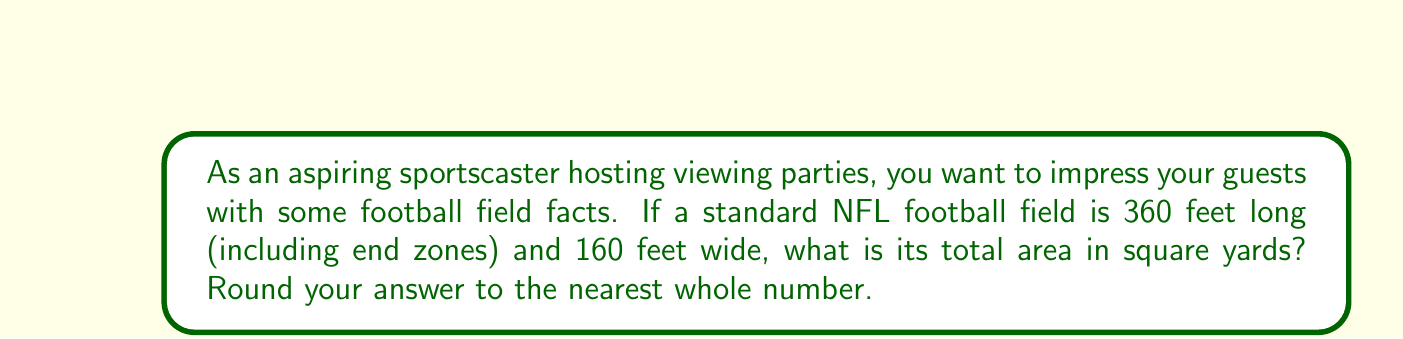Provide a solution to this math problem. Let's approach this step-by-step:

1) First, we need to recall the formula for the area of a rectangle:
   $$A = l \times w$$
   where $A$ is the area, $l$ is the length, and $w$ is the width.

2) We're given the dimensions in feet:
   Length ($l$) = 360 feet
   Width ($w$) = 160 feet

3) Let's substitute these into our formula:
   $$A = 360 \text{ ft} \times 160 \text{ ft} = 57,600 \text{ sq ft}$$

4) However, the question asks for the area in square yards. We need to convert square feet to square yards.

5) The conversion factor is: 1 square yard = 9 square feet
   So, we divide our result by 9:
   $$A_{\text{yards}} = \frac{57,600 \text{ sq ft}}{9 \text{ sq ft/sq yd}} = 6,400 \text{ sq yd}$$

6) The question asks to round to the nearest whole number, but our result is already a whole number.

[asy]
import geometry;

size(200);
draw((0,0)--(360,0)--(360,160)--(0,160)--cycle);
label("360 ft", (180,-10), S);
label("160 ft", (370,80), E);
label("Football Field", (180,80), N);
[/asy]
Answer: $6,400 \text{ sq yd}$ 